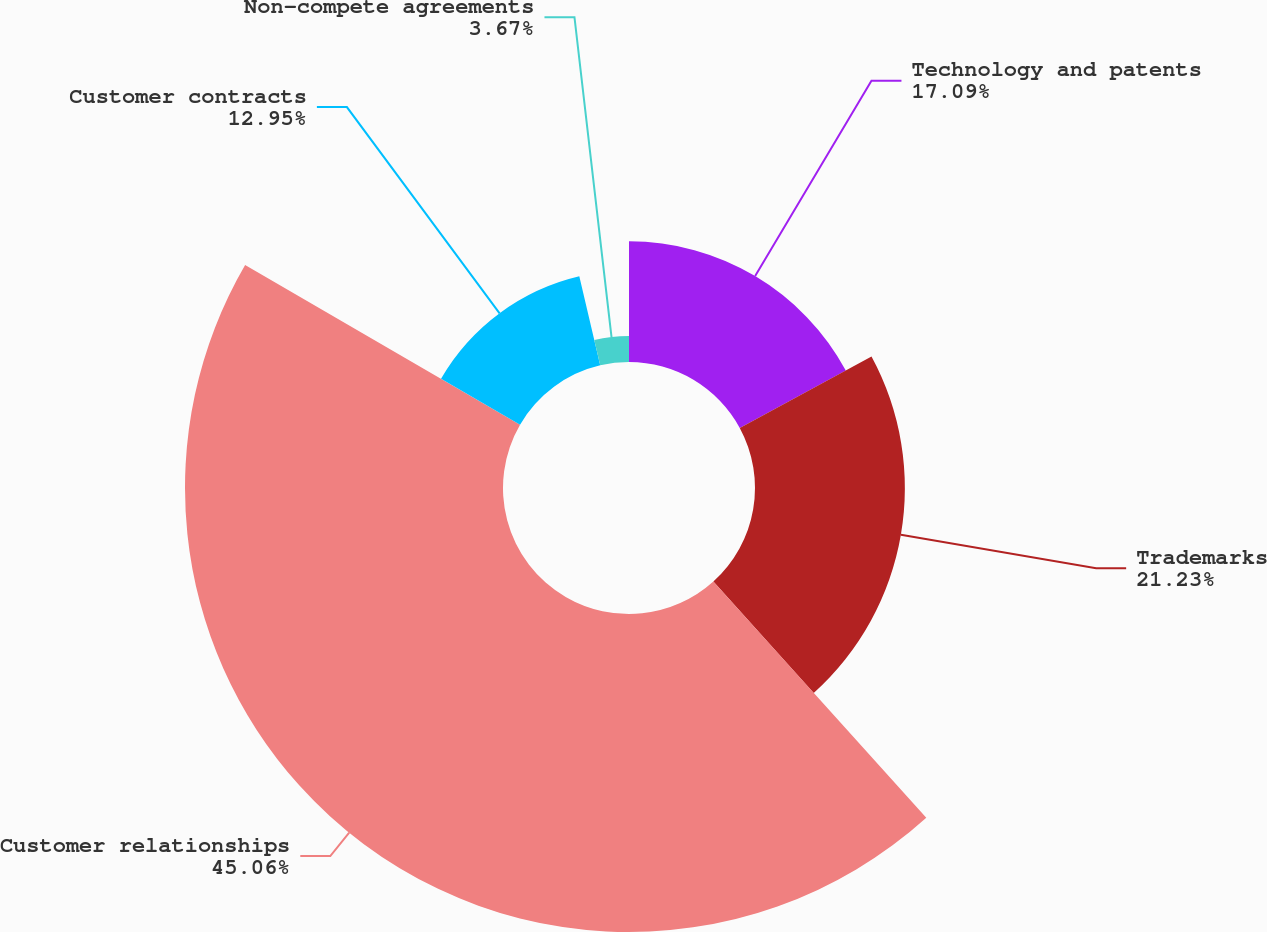Convert chart to OTSL. <chart><loc_0><loc_0><loc_500><loc_500><pie_chart><fcel>Technology and patents<fcel>Trademarks<fcel>Customer relationships<fcel>Customer contracts<fcel>Non-compete agreements<nl><fcel>17.09%<fcel>21.23%<fcel>45.05%<fcel>12.95%<fcel>3.67%<nl></chart> 